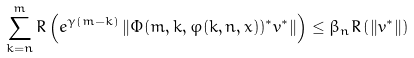<formula> <loc_0><loc_0><loc_500><loc_500>\sum _ { k = n } ^ { m } R \left ( e ^ { \gamma ( m - k ) } \left \| \Phi ( m , k , \varphi ( k , n , x ) ) ^ { * } v ^ { * } \right \| \right ) \leq \beta _ { n } R \left ( \left \| v ^ { * } \right \| \right )</formula> 